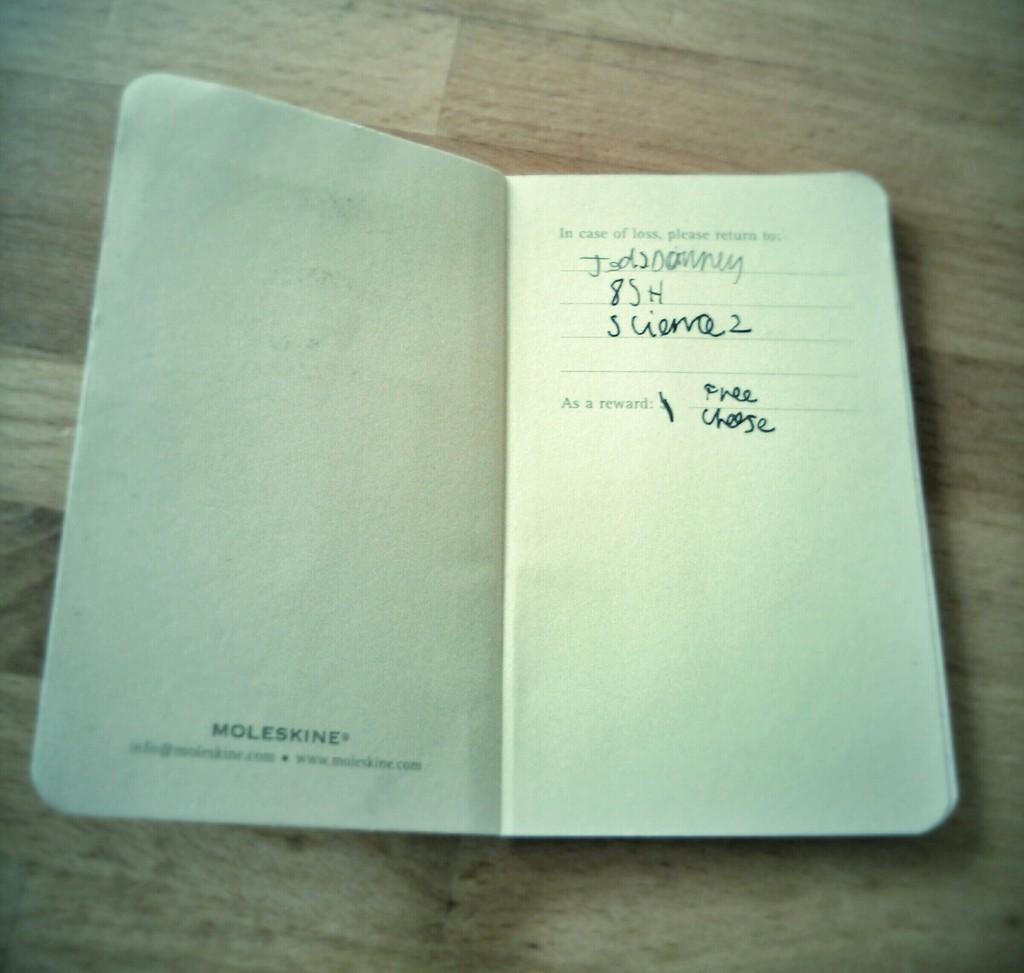<image>
Offer a succinct explanation of the picture presented. An open notebook that reads In case of loss return to. 